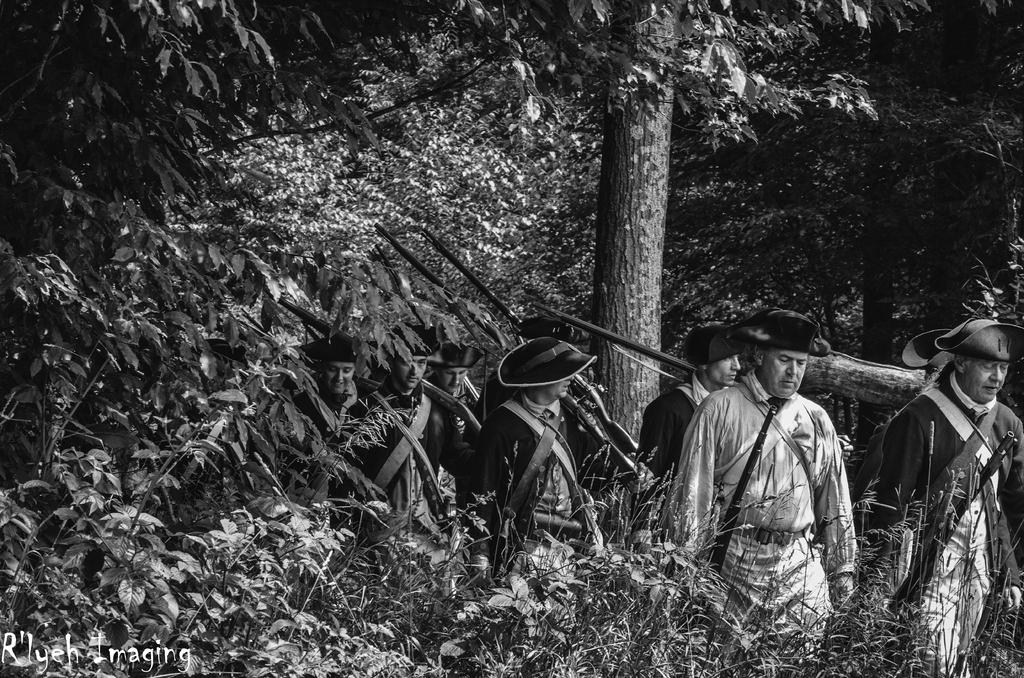What is happening on the right side of the image? There are people walking on the right side of the image. What type of vegetation can be seen in the image? There are plants and trees visible in the image. What type of jewel can be seen hanging from the trees in the image? There is no jewel present in the image; only plants and trees are visible. 